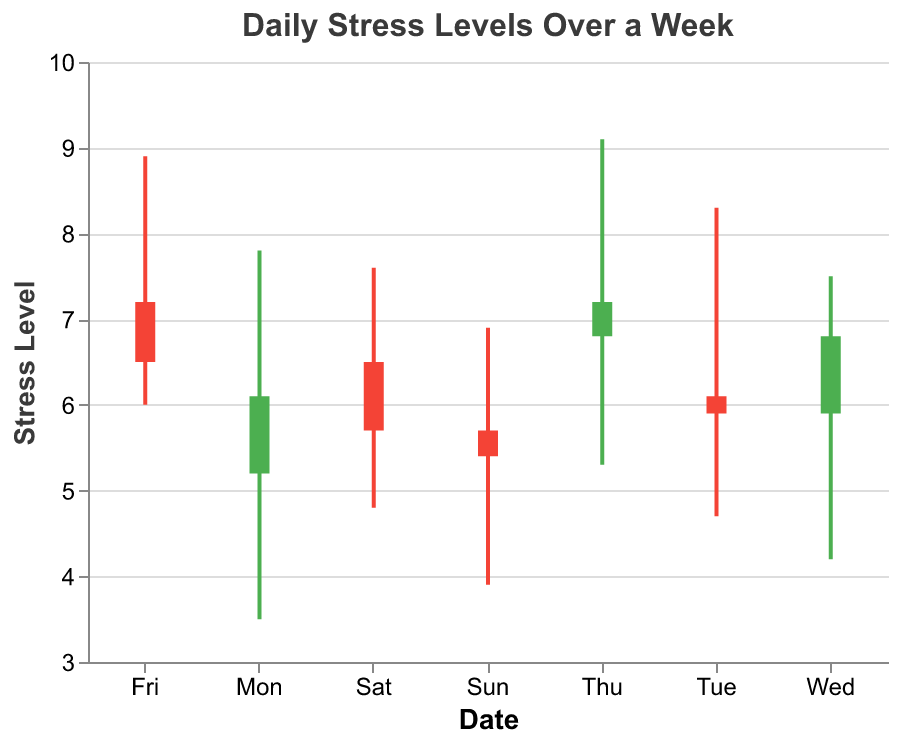What is the title of the chart? The title of the chart is displayed at the top and reads "Daily Stress Levels Over a Week".
Answer: Daily Stress Levels Over a Week How many days of data are shown in the chart? The x-axis denotes the days of the week, which list from "Mon" to "Sun", indicating a total of 7 days.
Answer: 7 On which day is the highest stress level recorded and what is that level? The highest stress level is indicated by the highest bar and the top of the thick lines. The highest value is 9.1, recorded on Thursday.
Answer: Thursday (9.1) What is the opening stress level on Friday? The opening stress level is represented by the lower end of the thick bar. On Friday, this value is 7.2.
Answer: 7.2 Which day saw the biggest fluctuation in stress levels? Fluctuation can be observed by the difference between the highest and lowest values for each day, shown by the vertical extent of the thin lines. Thursday has the biggest difference with a high of 9.1 and a low of 5.3, resulting in a fluctuation of 3.8.
Answer: Thursday What was the closing stress level on Sunday? The closing stress level is represented by the endpoint of the thick bar towards the top. For Sunday, this value is 5.4.
Answer: 5.4 Compare the opening stress levels on Monday and Wednesday. Which day had a higher opening value? Compare the lower endpoints of the thick bars for Monday and Wednesday; Monday has a value of 5.2 and Wednesday has a value of 5.9. Hence, Wednesday’s opening stress level is higher.
Answer: Wednesday What is the average of the high stress levels recorded on Monday and Friday? The high values for Monday (7.8) and Friday (8.9) can be averaged by adding them and dividing by 2. This calculation is (7.8 + 8.9) / 2 = 8.35.
Answer: 8.35 Identify the day with the lowest recorded stress level and specify that level. The lowest stress levels are indicated by the lowest endpoints of the thin lines, with Sunday showing the lowest value of 3.9.
Answer: Sunday (3.9) Which days had a closing stress level lower than their opening stress level, and what are those values? Closing values less than opening values are shown by bars with endpoints from top to bottom. These days are Tuesday (close 5.9, open 6.1), Friday (close 6.5, open 7.2), Saturday (close 5.7, open 6.5), and Sunday (close 5.4, open 5.7).
Answer: Tuesday, Friday, Saturday, Sunday 